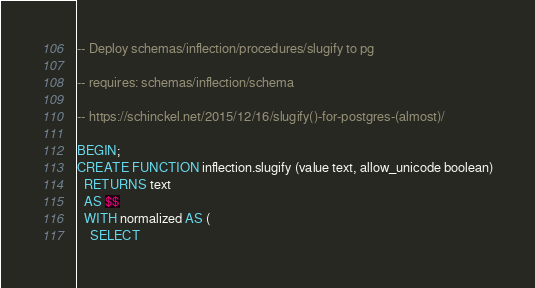Convert code to text. <code><loc_0><loc_0><loc_500><loc_500><_SQL_>-- Deploy schemas/inflection/procedures/slugify to pg

-- requires: schemas/inflection/schema

-- https://schinckel.net/2015/12/16/slugify()-for-postgres-(almost)/

BEGIN;
CREATE FUNCTION inflection.slugify (value text, allow_unicode boolean)
  RETURNS text
  AS $$
  WITH normalized AS (
    SELECT</code> 